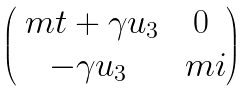<formula> <loc_0><loc_0><loc_500><loc_500>\begin{pmatrix} \ m t + \gamma u _ { 3 } & 0 \\ - \gamma u _ { 3 } & \ m i \end{pmatrix}</formula> 